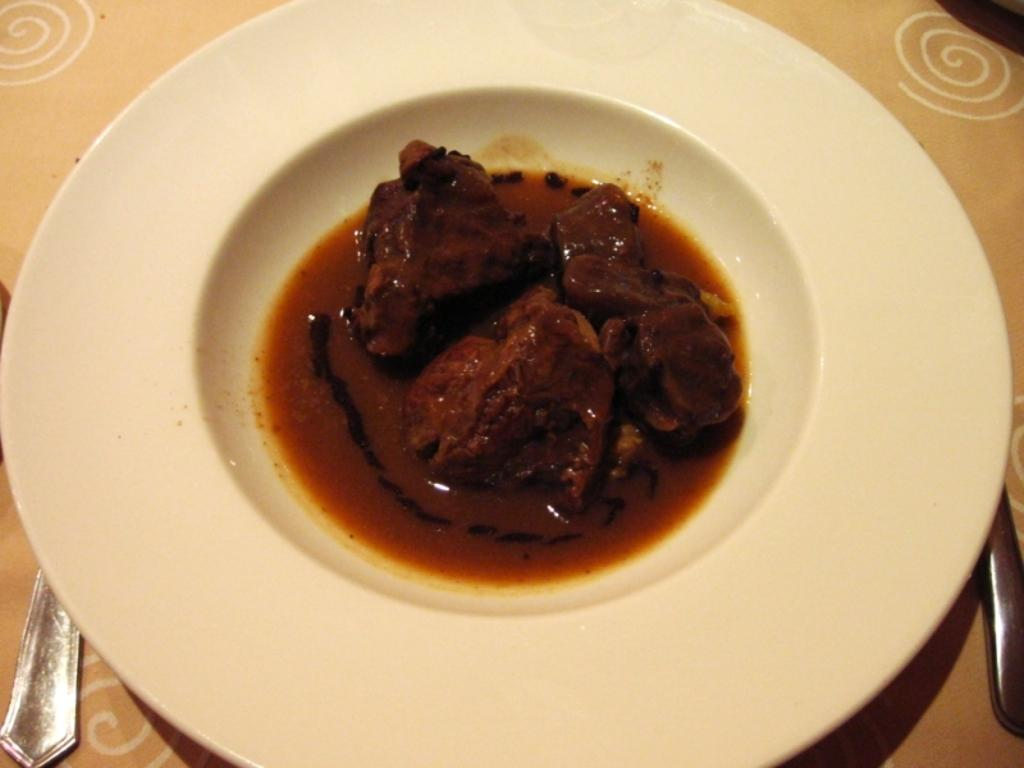What is on the plate that is visible in the image? There is a plate with food in the image. What utensils can be seen on the table in the image? There are spoons on the table in the image. What type of beast is sitting at the table in the image? There is no beast present in the image; it only shows a plate with food and spoons on the table. 